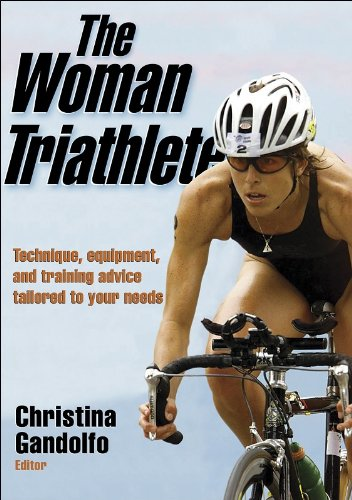Can this book be useful for beginners in triathlon? Absolutely, 'The Woman Triathlete' is tailored to suit the needs of various skill levels, including beginners. It offers detailed information on the technique, equipment, and training necessary to embark on triathlon, making it quite beneficial for newcomers. 